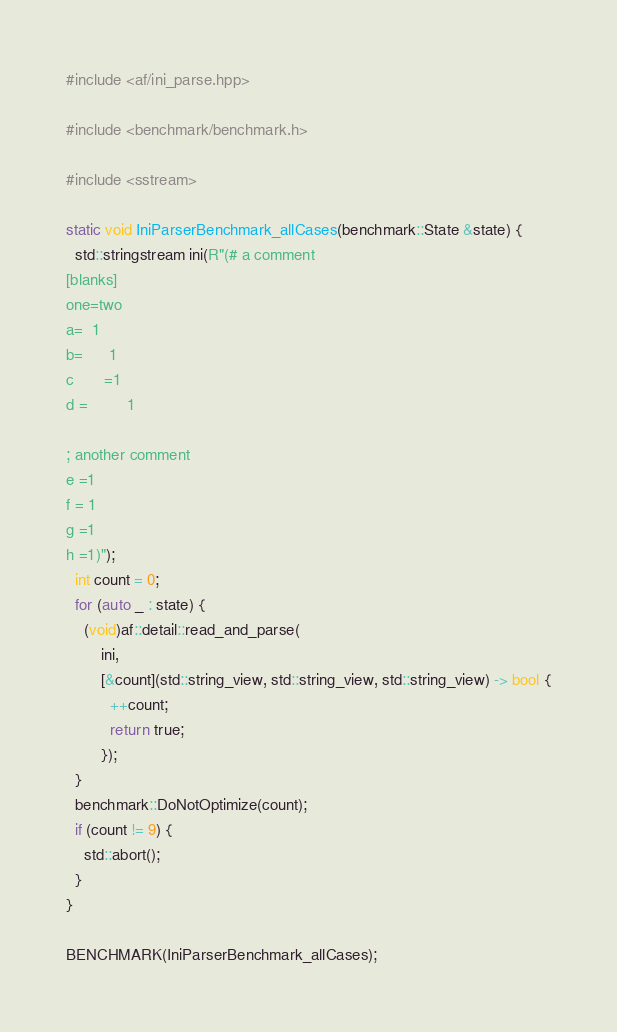Convert code to text. <code><loc_0><loc_0><loc_500><loc_500><_C++_>#include <af/ini_parse.hpp>

#include <benchmark/benchmark.h>

#include <sstream>

static void IniParserBenchmark_allCases(benchmark::State &state) {
  std::stringstream ini(R"(# a comment
[blanks]
one=two
a=  1
b=      1   
c       =1
d =         1

; another comment   
e =1        
f = 1   
g =1      
h =1)");
  int count = 0;
  for (auto _ : state) {
    (void)af::detail::read_and_parse(
        ini,
        [&count](std::string_view, std::string_view, std::string_view) -> bool {
          ++count;
          return true;
        });
  }
  benchmark::DoNotOptimize(count);
  if (count != 9) {
    std::abort();
  }
}

BENCHMARK(IniParserBenchmark_allCases);
</code> 